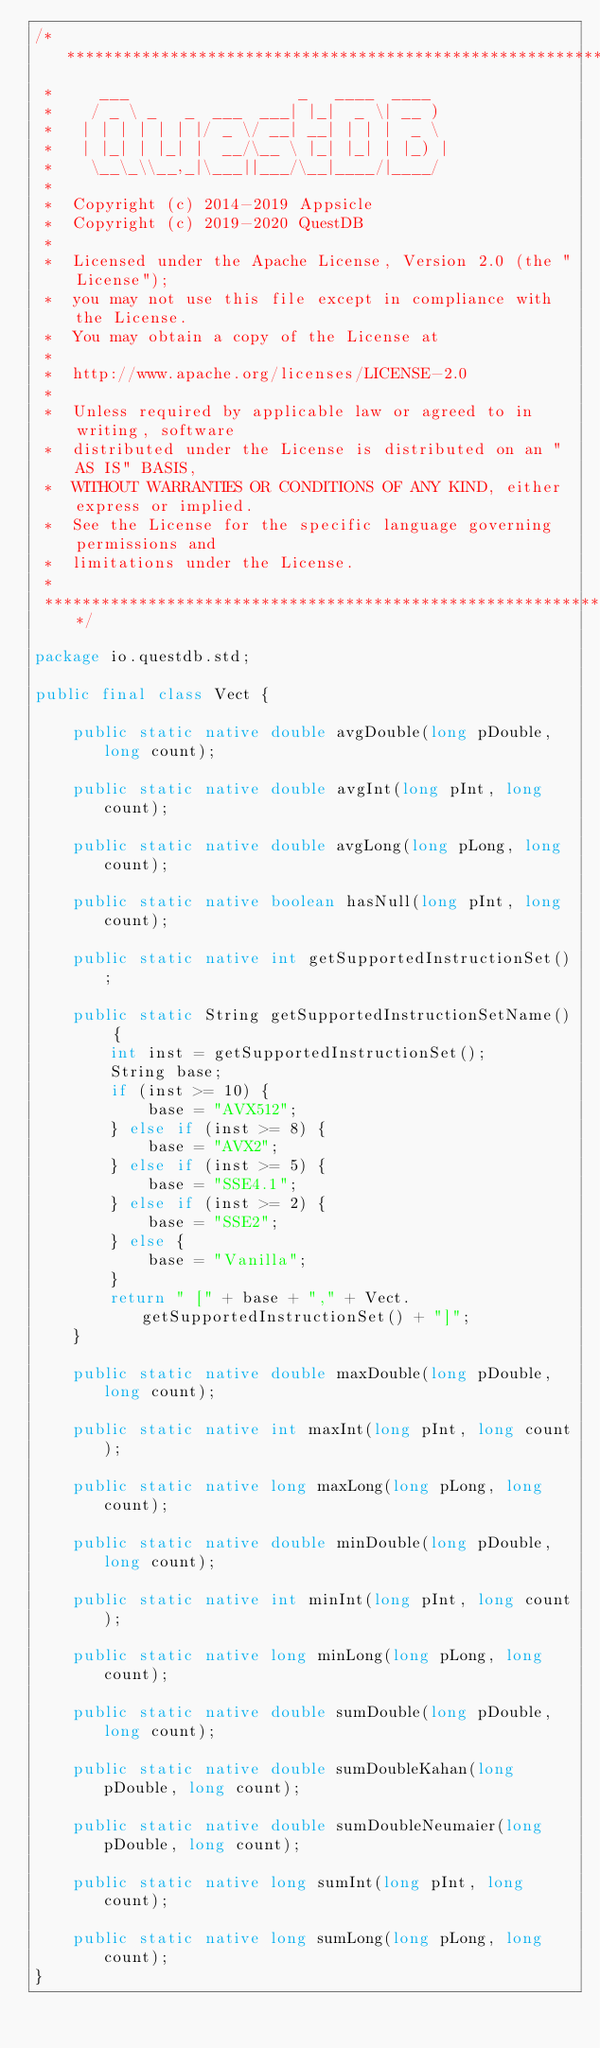<code> <loc_0><loc_0><loc_500><loc_500><_Java_>/*******************************************************************************
 *     ___                  _   ____  ____
 *    / _ \ _   _  ___  ___| |_|  _ \| __ )
 *   | | | | | | |/ _ \/ __| __| | | |  _ \
 *   | |_| | |_| |  __/\__ \ |_| |_| | |_) |
 *    \__\_\\__,_|\___||___/\__|____/|____/
 *
 *  Copyright (c) 2014-2019 Appsicle
 *  Copyright (c) 2019-2020 QuestDB
 *
 *  Licensed under the Apache License, Version 2.0 (the "License");
 *  you may not use this file except in compliance with the License.
 *  You may obtain a copy of the License at
 *
 *  http://www.apache.org/licenses/LICENSE-2.0
 *
 *  Unless required by applicable law or agreed to in writing, software
 *  distributed under the License is distributed on an "AS IS" BASIS,
 *  WITHOUT WARRANTIES OR CONDITIONS OF ANY KIND, either express or implied.
 *  See the License for the specific language governing permissions and
 *  limitations under the License.
 *
 ******************************************************************************/

package io.questdb.std;

public final class Vect {

    public static native double avgDouble(long pDouble, long count);

    public static native double avgInt(long pInt, long count);

    public static native double avgLong(long pLong, long count);

    public static native boolean hasNull(long pInt, long count);

    public static native int getSupportedInstructionSet();

    public static String getSupportedInstructionSetName() {
        int inst = getSupportedInstructionSet();
        String base;
        if (inst >= 10) {
            base = "AVX512";
        } else if (inst >= 8) {
            base = "AVX2";
        } else if (inst >= 5) {
            base = "SSE4.1";
        } else if (inst >= 2) {
            base = "SSE2";
        } else {
            base = "Vanilla";
        }
        return " [" + base + "," + Vect.getSupportedInstructionSet() + "]";
    }

    public static native double maxDouble(long pDouble, long count);

    public static native int maxInt(long pInt, long count);

    public static native long maxLong(long pLong, long count);

    public static native double minDouble(long pDouble, long count);

    public static native int minInt(long pInt, long count);

    public static native long minLong(long pLong, long count);

    public static native double sumDouble(long pDouble, long count);

    public static native double sumDoubleKahan(long pDouble, long count);

    public static native double sumDoubleNeumaier(long pDouble, long count);

    public static native long sumInt(long pInt, long count);

    public static native long sumLong(long pLong, long count);
}
</code> 